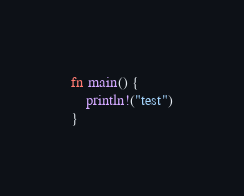<code> <loc_0><loc_0><loc_500><loc_500><_Rust_>fn main() {
    println!("test")
}</code> 